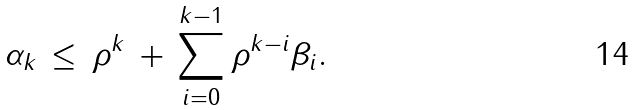Convert formula to latex. <formula><loc_0><loc_0><loc_500><loc_500>\alpha _ { k } \, \leq \, \rho ^ { k } \, + \, \sum _ { i = 0 } ^ { k - 1 } \rho ^ { k - i } \beta _ { i } .</formula> 